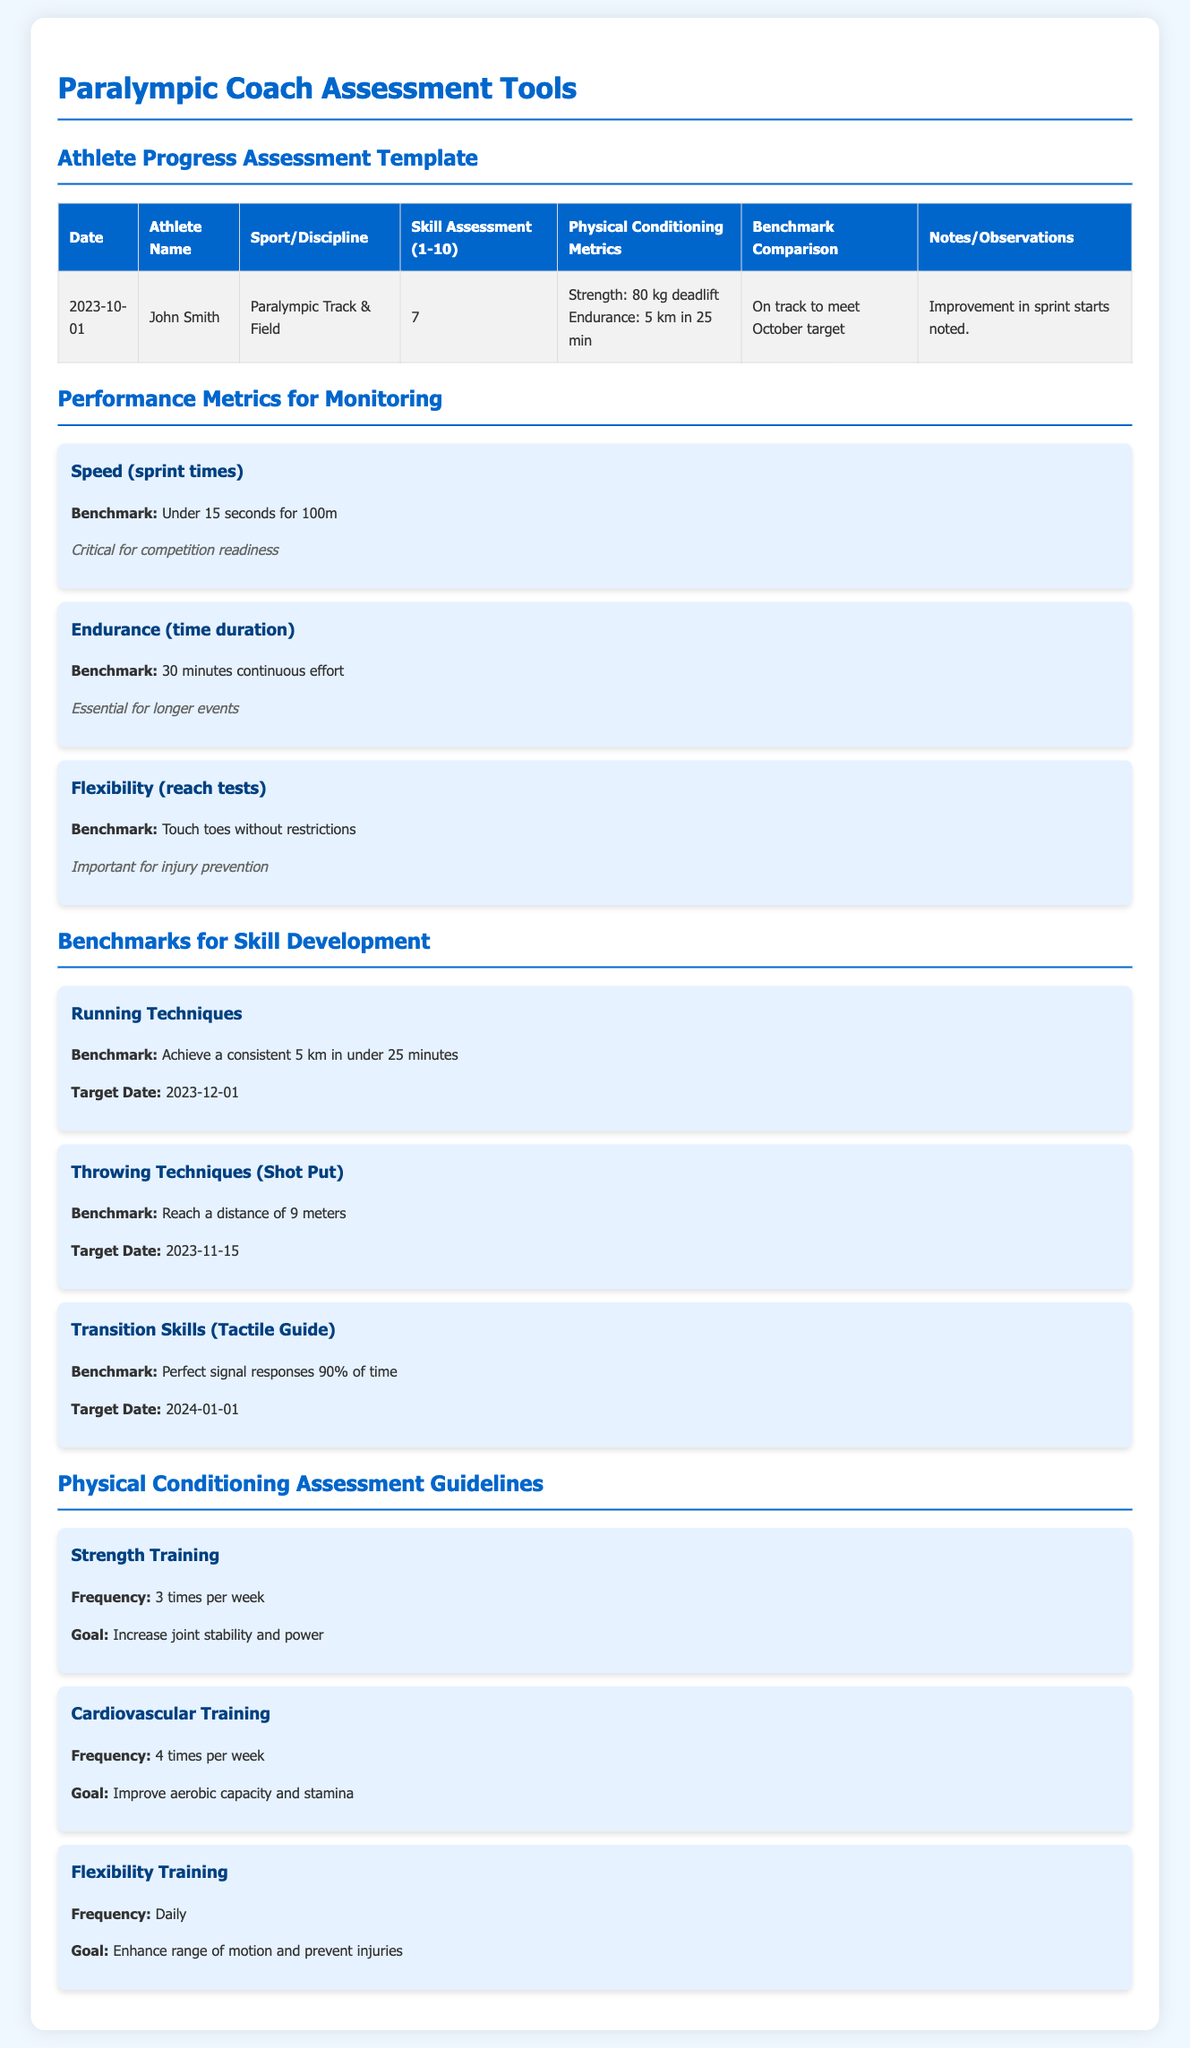What is the athlete's name? The athlete's name listed in the assessment template is John Smith.
Answer: John Smith What is the benchmark for speed in sprint times? The benchmark for speed in sprint times is under 15 seconds for 100m.
Answer: Under 15 seconds for 100m What date is the target for achieving a consistent 5 km in under 25 minutes? The target date for this benchmark is December 1, 2023.
Answer: 2023-12-01 How often should strength training be conducted? The frequency for strength training is mentioned as 3 times per week.
Answer: 3 times per week What is the current deadlift strength measurement for the athlete? The athlete's current deadlift strength is 80 kg.
Answer: 80 kg What sport does the athlete participate in? The sport that John Smith participates in is Paralympic Track & Field.
Answer: Paralympic Track & Field What skill assessment rating did the athlete receive? The skill assessment rating for the athlete is 7.
Answer: 7 What is the goal for cardiovascular training? The goal for cardiovascular training is to improve aerobic capacity and stamina.
Answer: Improve aerobic capacity and stamina What improvement was noted in the observations? The observation noted an improvement in sprint starts.
Answer: Improvement in sprint starts noted 